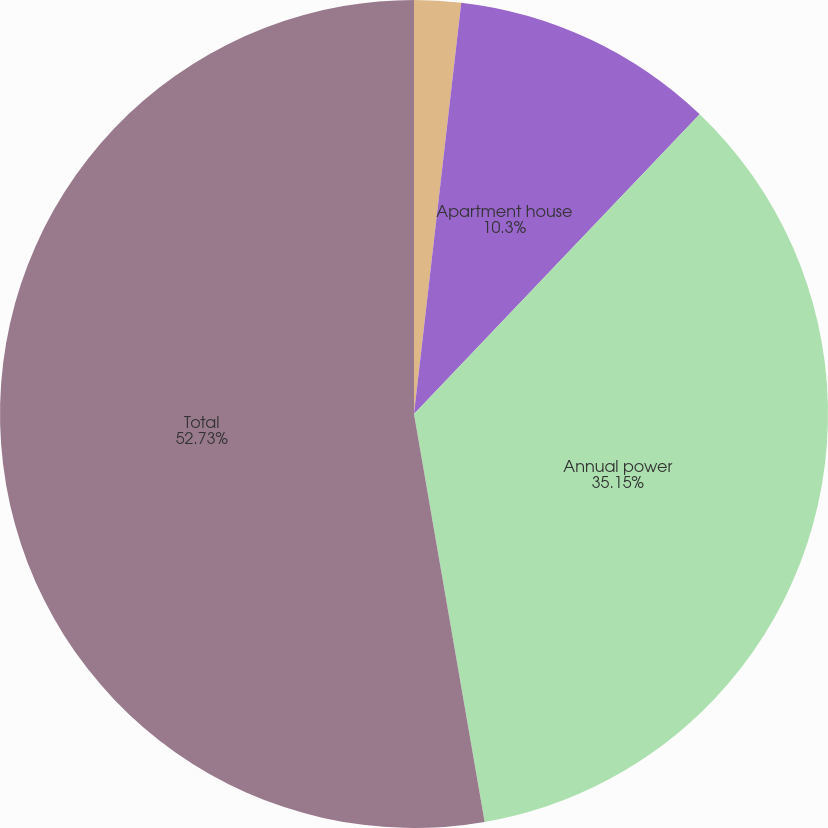<chart> <loc_0><loc_0><loc_500><loc_500><pie_chart><fcel>General<fcel>Apartment house<fcel>Annual power<fcel>Total<nl><fcel>1.82%<fcel>10.3%<fcel>35.15%<fcel>52.73%<nl></chart> 